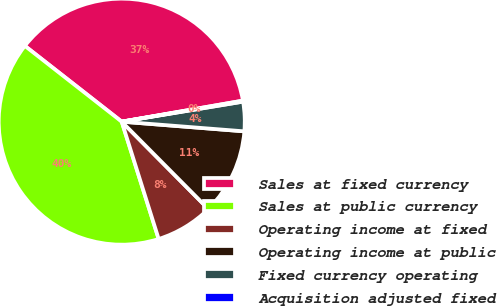Convert chart to OTSL. <chart><loc_0><loc_0><loc_500><loc_500><pie_chart><fcel>Sales at fixed currency<fcel>Sales at public currency<fcel>Operating income at fixed<fcel>Operating income at public<fcel>Fixed currency operating<fcel>Acquisition adjusted fixed<nl><fcel>36.7%<fcel>40.42%<fcel>7.58%<fcel>11.31%<fcel>3.86%<fcel>0.13%<nl></chart> 